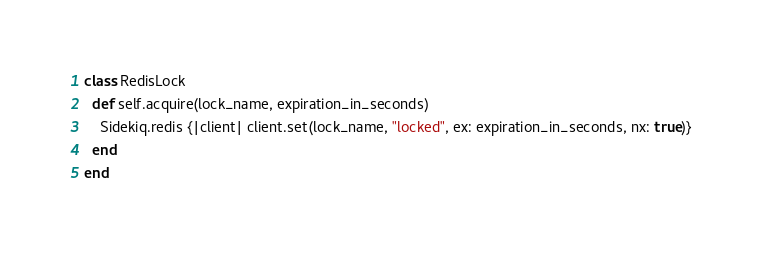<code> <loc_0><loc_0><loc_500><loc_500><_Ruby_>class RedisLock
  def self.acquire(lock_name, expiration_in_seconds)
    Sidekiq.redis {|client| client.set(lock_name, "locked", ex: expiration_in_seconds, nx: true)}
  end
end</code> 